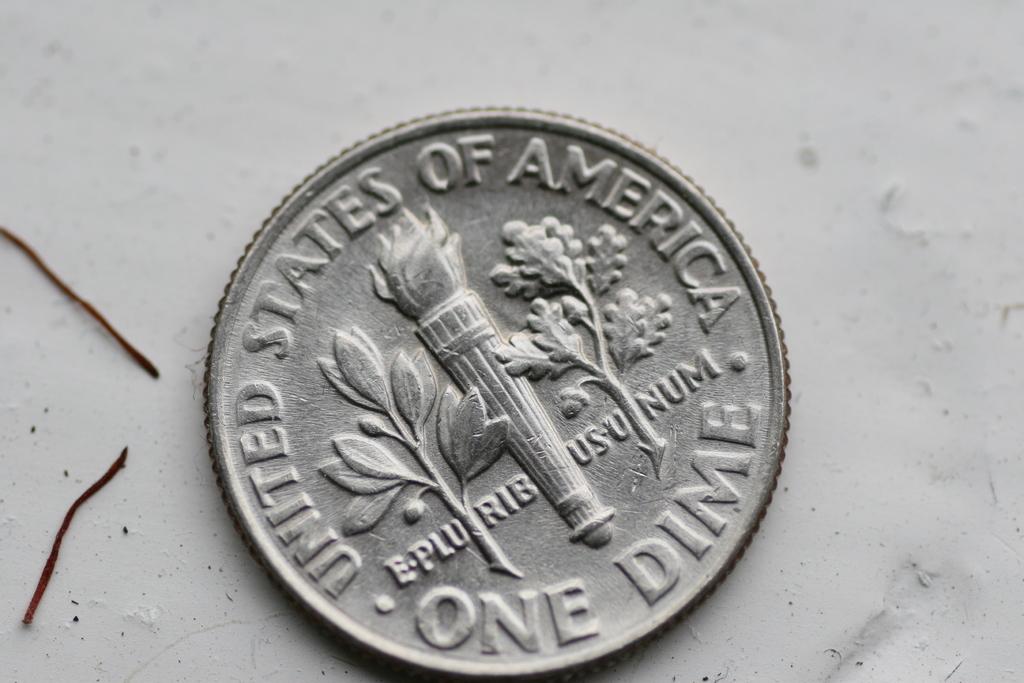What is the name of this type of currency?
Your response must be concise. Dime. What does it say on the top half of the coin?
Your response must be concise. United states of america. 